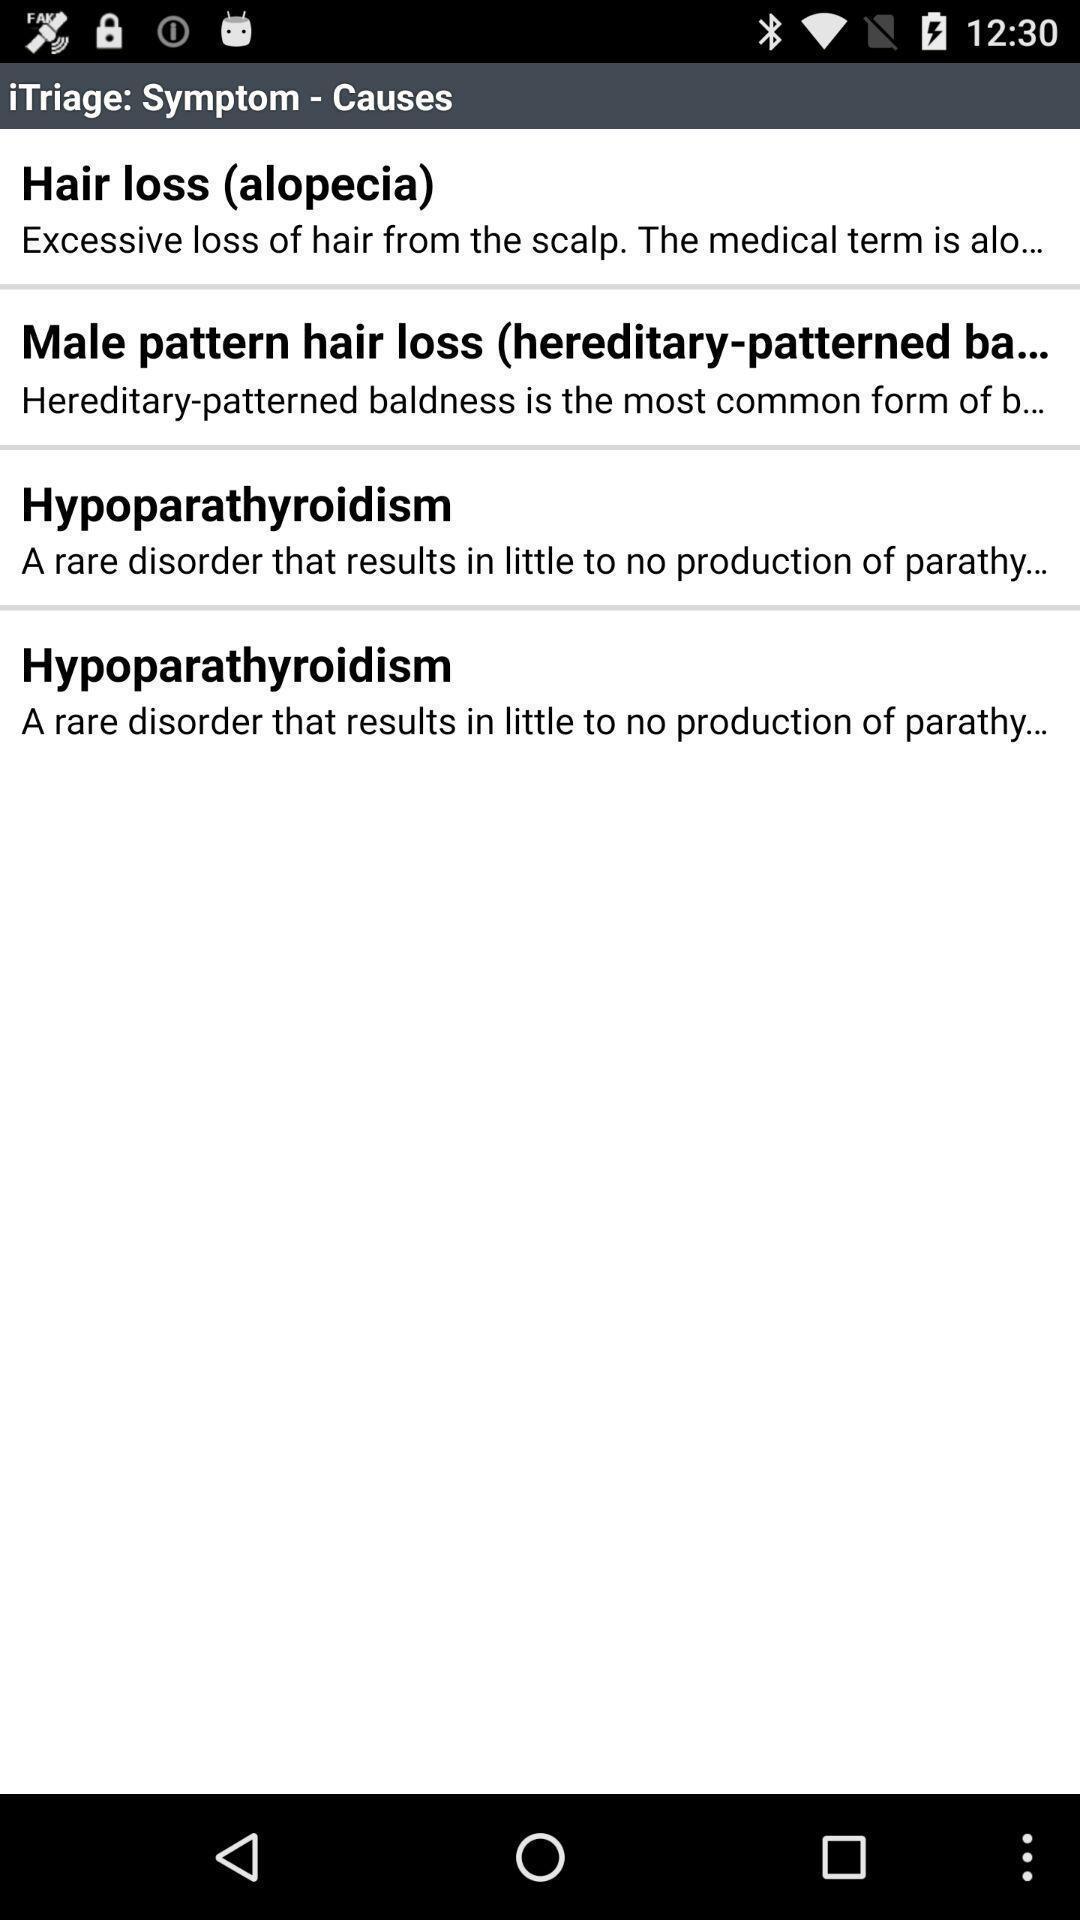Provide a description of this screenshot. Screen display symptoms page in a health app. 